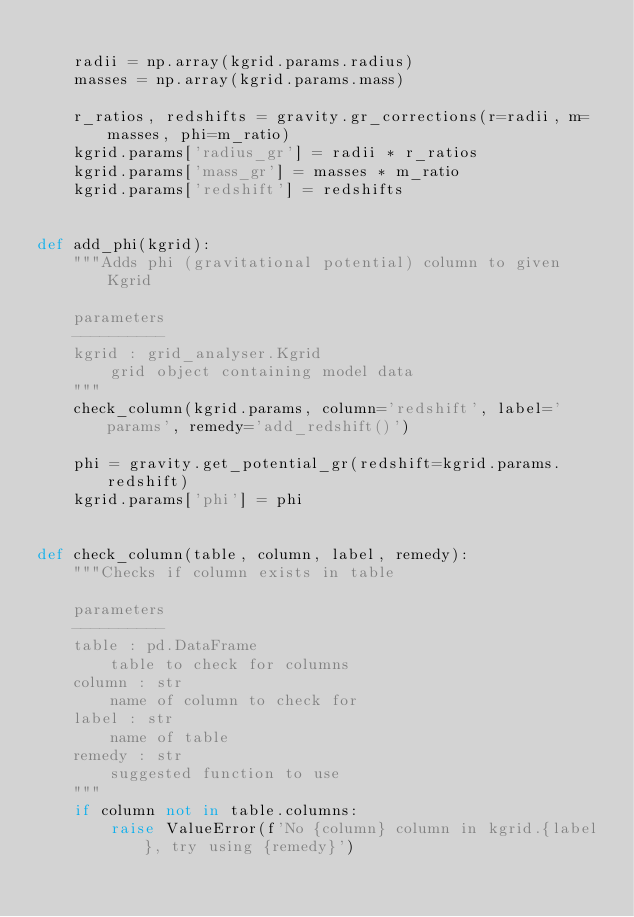Convert code to text. <code><loc_0><loc_0><loc_500><loc_500><_Python_>
    radii = np.array(kgrid.params.radius)
    masses = np.array(kgrid.params.mass)

    r_ratios, redshifts = gravity.gr_corrections(r=radii, m=masses, phi=m_ratio)
    kgrid.params['radius_gr'] = radii * r_ratios
    kgrid.params['mass_gr'] = masses * m_ratio
    kgrid.params['redshift'] = redshifts


def add_phi(kgrid):
    """Adds phi (gravitational potential) column to given Kgrid

    parameters
    ----------
    kgrid : grid_analyser.Kgrid
        grid object containing model data
    """
    check_column(kgrid.params, column='redshift', label='params', remedy='add_redshift()')

    phi = gravity.get_potential_gr(redshift=kgrid.params.redshift)
    kgrid.params['phi'] = phi


def check_column(table, column, label, remedy):
    """Checks if column exists in table

    parameters
    ----------
    table : pd.DataFrame
        table to check for columns
    column : str
        name of column to check for
    label : str
        name of table
    remedy : str
        suggested function to use
    """
    if column not in table.columns:
        raise ValueError(f'No {column} column in kgrid.{label}, try using {remedy}')
</code> 